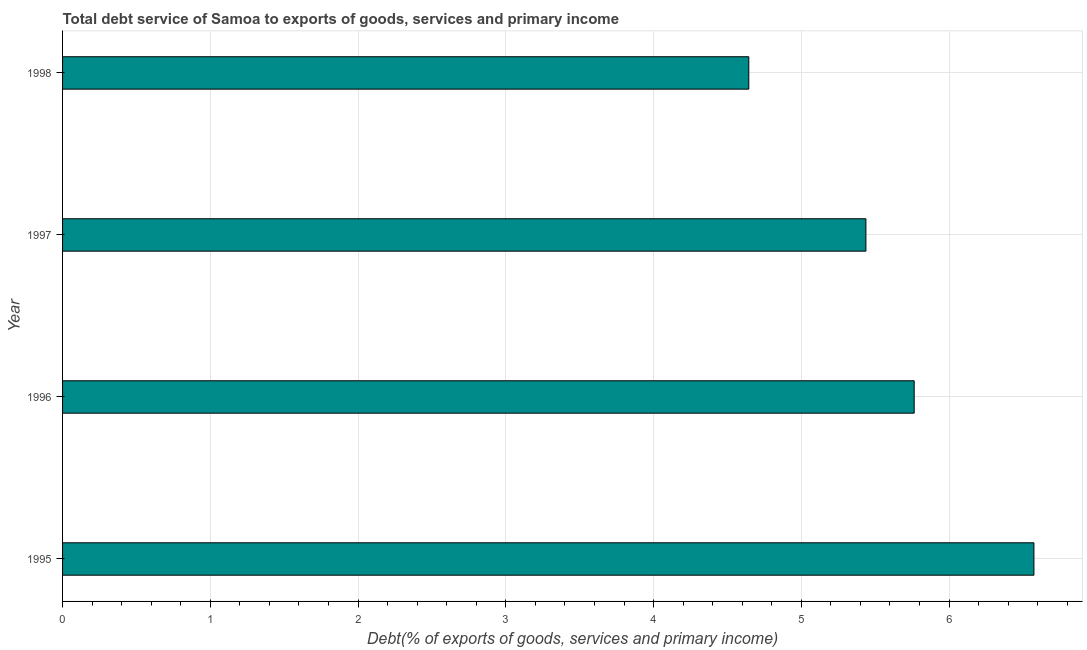Does the graph contain any zero values?
Your answer should be compact. No. What is the title of the graph?
Offer a terse response. Total debt service of Samoa to exports of goods, services and primary income. What is the label or title of the X-axis?
Offer a terse response. Debt(% of exports of goods, services and primary income). What is the total debt service in 1996?
Give a very brief answer. 5.76. Across all years, what is the maximum total debt service?
Your answer should be compact. 6.57. Across all years, what is the minimum total debt service?
Your answer should be compact. 4.64. What is the sum of the total debt service?
Offer a terse response. 22.42. What is the difference between the total debt service in 1996 and 1998?
Offer a very short reply. 1.12. What is the average total debt service per year?
Offer a terse response. 5.61. What is the median total debt service?
Your answer should be very brief. 5.6. Do a majority of the years between 1997 and 1996 (inclusive) have total debt service greater than 2.6 %?
Your answer should be compact. No. What is the ratio of the total debt service in 1996 to that in 1997?
Offer a very short reply. 1.06. What is the difference between the highest and the second highest total debt service?
Your answer should be compact. 0.81. What is the difference between the highest and the lowest total debt service?
Make the answer very short. 1.93. In how many years, is the total debt service greater than the average total debt service taken over all years?
Provide a short and direct response. 2. Are all the bars in the graph horizontal?
Give a very brief answer. Yes. How many years are there in the graph?
Your response must be concise. 4. Are the values on the major ticks of X-axis written in scientific E-notation?
Your answer should be very brief. No. What is the Debt(% of exports of goods, services and primary income) of 1995?
Give a very brief answer. 6.57. What is the Debt(% of exports of goods, services and primary income) in 1996?
Give a very brief answer. 5.76. What is the Debt(% of exports of goods, services and primary income) in 1997?
Offer a terse response. 5.44. What is the Debt(% of exports of goods, services and primary income) of 1998?
Ensure brevity in your answer.  4.64. What is the difference between the Debt(% of exports of goods, services and primary income) in 1995 and 1996?
Provide a short and direct response. 0.81. What is the difference between the Debt(% of exports of goods, services and primary income) in 1995 and 1997?
Make the answer very short. 1.14. What is the difference between the Debt(% of exports of goods, services and primary income) in 1995 and 1998?
Your answer should be compact. 1.93. What is the difference between the Debt(% of exports of goods, services and primary income) in 1996 and 1997?
Your answer should be very brief. 0.33. What is the difference between the Debt(% of exports of goods, services and primary income) in 1996 and 1998?
Your response must be concise. 1.12. What is the difference between the Debt(% of exports of goods, services and primary income) in 1997 and 1998?
Your response must be concise. 0.79. What is the ratio of the Debt(% of exports of goods, services and primary income) in 1995 to that in 1996?
Give a very brief answer. 1.14. What is the ratio of the Debt(% of exports of goods, services and primary income) in 1995 to that in 1997?
Provide a succinct answer. 1.21. What is the ratio of the Debt(% of exports of goods, services and primary income) in 1995 to that in 1998?
Give a very brief answer. 1.42. What is the ratio of the Debt(% of exports of goods, services and primary income) in 1996 to that in 1997?
Your answer should be compact. 1.06. What is the ratio of the Debt(% of exports of goods, services and primary income) in 1996 to that in 1998?
Your response must be concise. 1.24. What is the ratio of the Debt(% of exports of goods, services and primary income) in 1997 to that in 1998?
Keep it short and to the point. 1.17. 